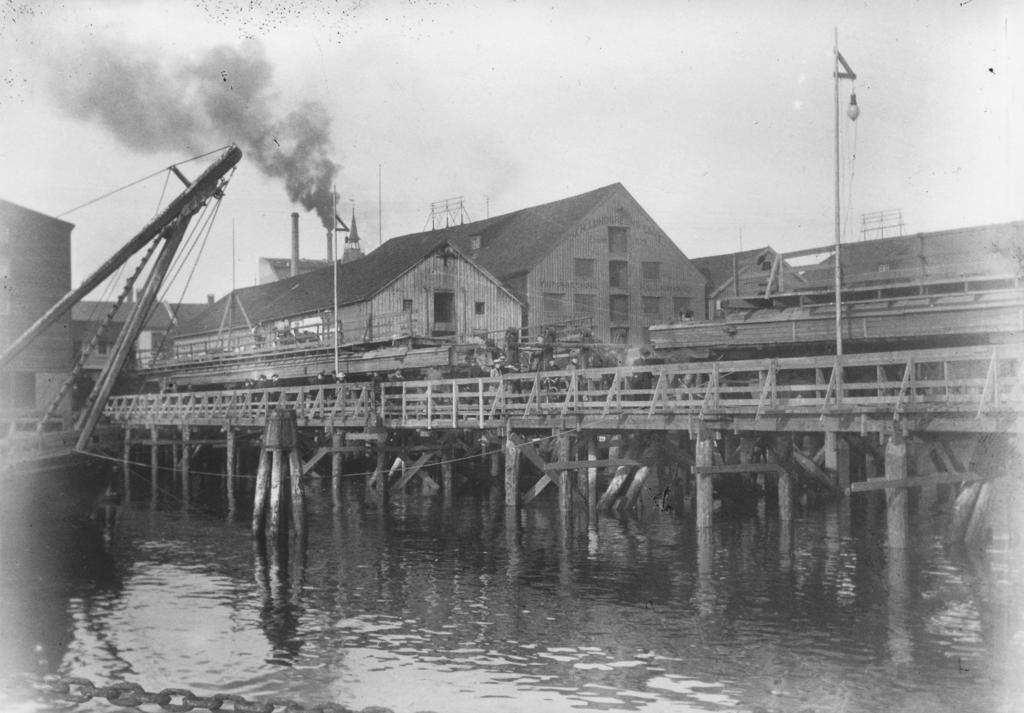Please provide a concise description of this image. This is a black and white picture, in this image we can see a bridge above the water, there are some buildings, windows, poles and a light, also we can see a crane and in the background, we can see the sky. 